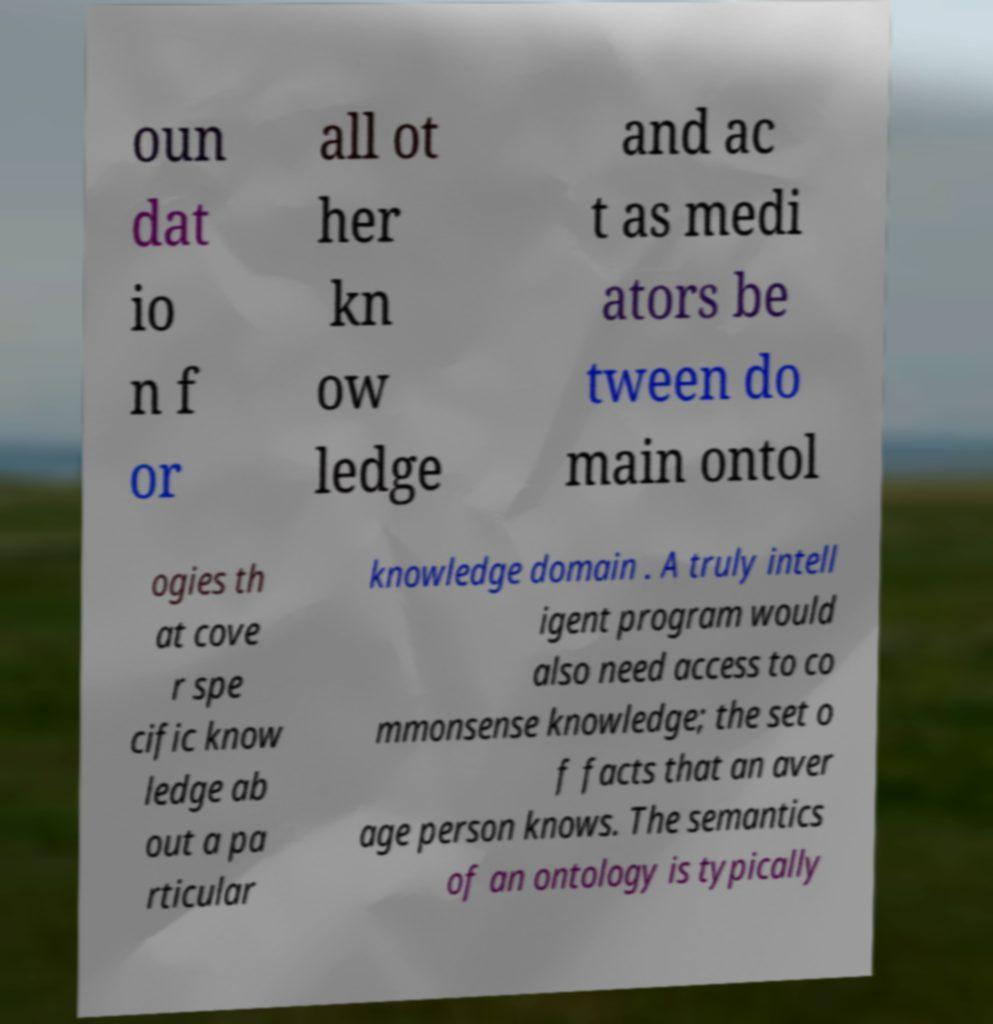I need the written content from this picture converted into text. Can you do that? oun dat io n f or all ot her kn ow ledge and ac t as medi ators be tween do main ontol ogies th at cove r spe cific know ledge ab out a pa rticular knowledge domain . A truly intell igent program would also need access to co mmonsense knowledge; the set o f facts that an aver age person knows. The semantics of an ontology is typically 